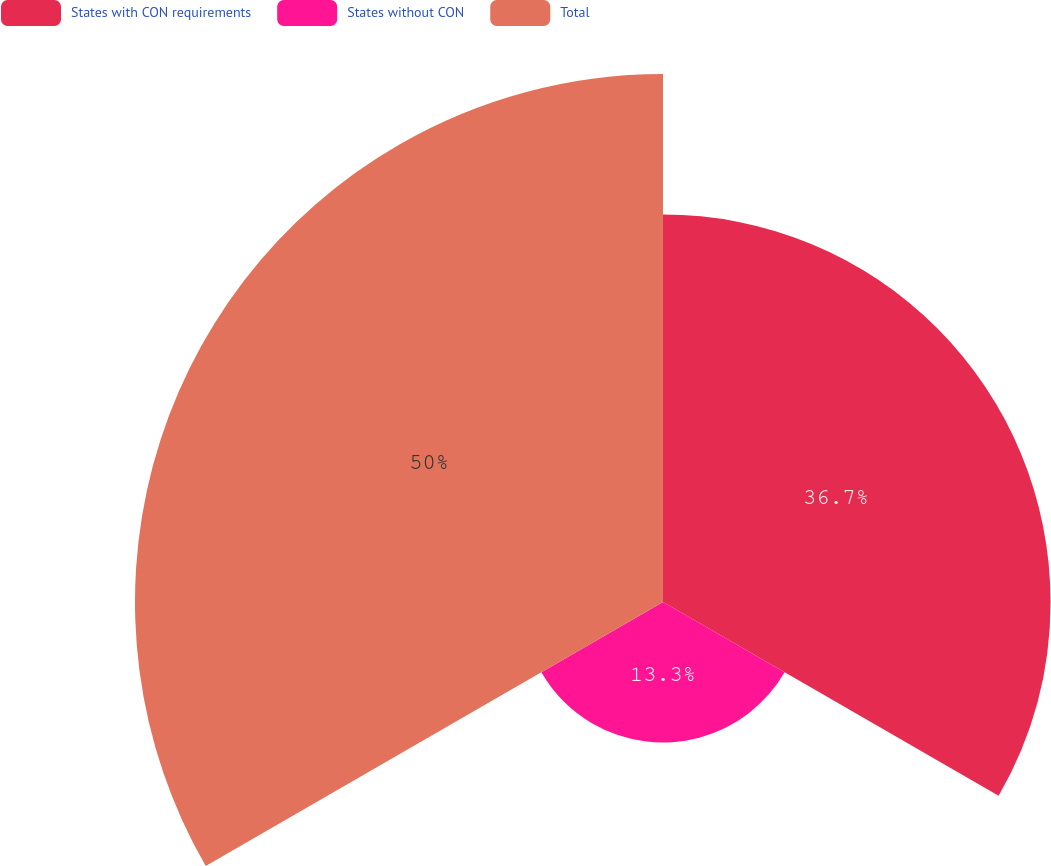Convert chart. <chart><loc_0><loc_0><loc_500><loc_500><pie_chart><fcel>States with CON requirements<fcel>States without CON<fcel>Total<nl><fcel>36.7%<fcel>13.3%<fcel>50.0%<nl></chart> 